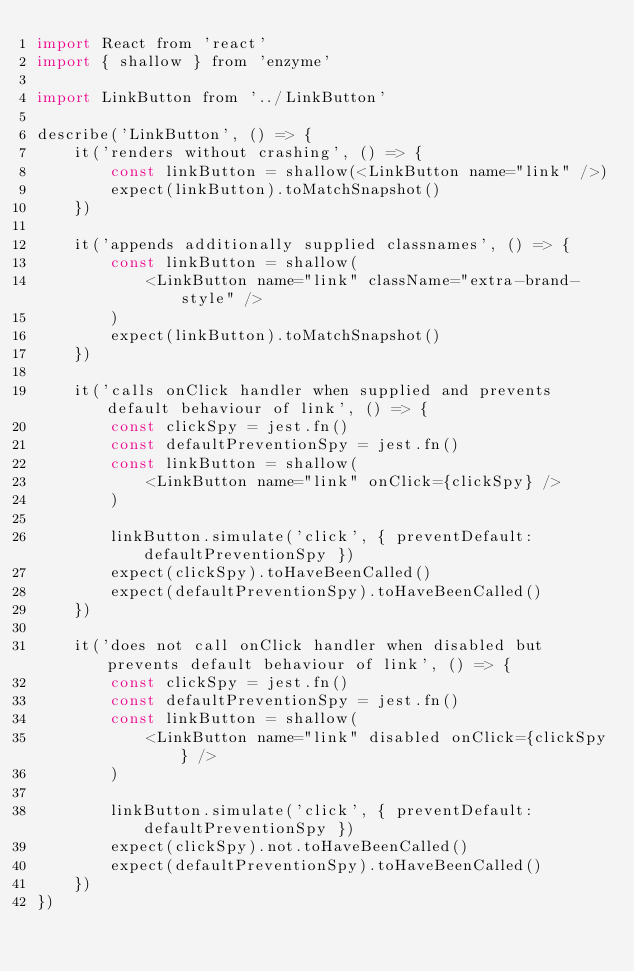Convert code to text. <code><loc_0><loc_0><loc_500><loc_500><_JavaScript_>import React from 'react'
import { shallow } from 'enzyme'

import LinkButton from '../LinkButton'

describe('LinkButton', () => {
    it('renders without crashing', () => {
        const linkButton = shallow(<LinkButton name="link" />)
        expect(linkButton).toMatchSnapshot()
    })

    it('appends additionally supplied classnames', () => {
        const linkButton = shallow(
            <LinkButton name="link" className="extra-brand-style" />
        )
        expect(linkButton).toMatchSnapshot()
    })

    it('calls onClick handler when supplied and prevents default behaviour of link', () => {
        const clickSpy = jest.fn()
        const defaultPreventionSpy = jest.fn()
        const linkButton = shallow(
            <LinkButton name="link" onClick={clickSpy} />
        )

        linkButton.simulate('click', { preventDefault: defaultPreventionSpy })
        expect(clickSpy).toHaveBeenCalled()
        expect(defaultPreventionSpy).toHaveBeenCalled()
    })

    it('does not call onClick handler when disabled but prevents default behaviour of link', () => {
        const clickSpy = jest.fn()
        const defaultPreventionSpy = jest.fn()
        const linkButton = shallow(
            <LinkButton name="link" disabled onClick={clickSpy} />
        )

        linkButton.simulate('click', { preventDefault: defaultPreventionSpy })
        expect(clickSpy).not.toHaveBeenCalled()
        expect(defaultPreventionSpy).toHaveBeenCalled()
    })
})
</code> 